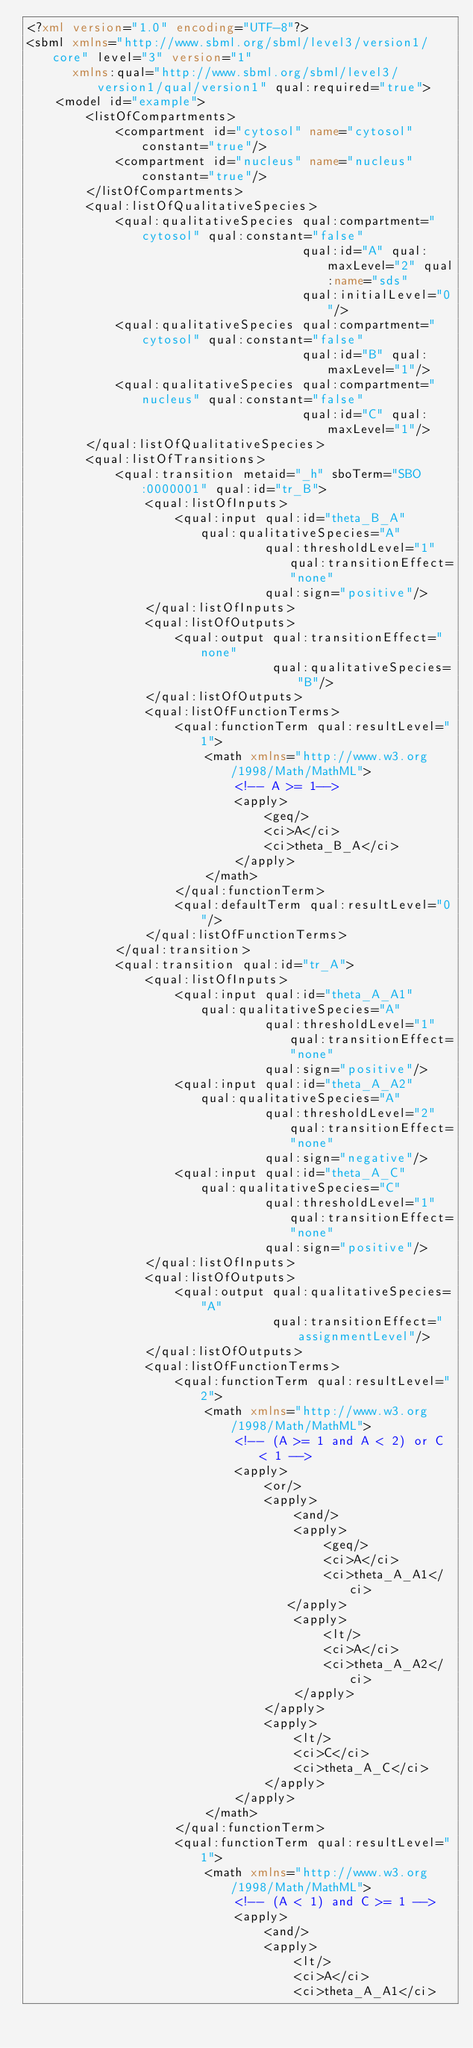<code> <loc_0><loc_0><loc_500><loc_500><_XML_><?xml version="1.0" encoding="UTF-8"?>
<sbml xmlns="http://www.sbml.org/sbml/level3/version1/core" level="3" version="1"
      xmlns:qual="http://www.sbml.org/sbml/level3/version1/qual/version1" qual:required="true">
    <model id="example">	
        <listOfCompartments>
            <compartment id="cytosol" name="cytosol" constant="true"/>
            <compartment id="nucleus" name="nucleus" constant="true"/>
        </listOfCompartments>
        <qual:listOfQualitativeSpecies>
            <qual:qualitativeSpecies qual:compartment="cytosol" qual:constant="false" 
                                     qual:id="A" qual:maxLevel="2" qual:name="sds"
                                     qual:initialLevel="0"/>
            <qual:qualitativeSpecies qual:compartment="cytosol" qual:constant="false" 
                                     qual:id="B" qual:maxLevel="1"/>
            <qual:qualitativeSpecies qual:compartment="nucleus" qual:constant="false" 
                                     qual:id="C" qual:maxLevel="1"/>
        </qual:listOfQualitativeSpecies>
        <qual:listOfTransitions>
            <qual:transition metaid="_h" sboTerm="SBO:0000001" qual:id="tr_B">
                <qual:listOfInputs>
                    <qual:input qual:id="theta_B_A"     qual:qualitativeSpecies="A" 
                                qual:thresholdLevel="1"  qual:transitionEffect="none" 
                                qual:sign="positive"/>
                </qual:listOfInputs>
                <qual:listOfOutputs>
                    <qual:output qual:transitionEffect="none" 
                                 qual:qualitativeSpecies="B"/>
                </qual:listOfOutputs>
                <qual:listOfFunctionTerms>
                    <qual:functionTerm qual:resultLevel="1">
                        <math xmlns="http://www.w3.org/1998/Math/MathML"> 
                            <!-- A >= 1-->
                            <apply>
                                <geq/>
                                <ci>A</ci>
                                <ci>theta_B_A</ci>
                            </apply>
                        </math>
                    </qual:functionTerm>
                    <qual:defaultTerm qual:resultLevel="0"/>
                </qual:listOfFunctionTerms>
            </qual:transition>
            <qual:transition qual:id="tr_A">
                <qual:listOfInputs>
                    <qual:input qual:id="theta_A_A1"     qual:qualitativeSpecies="A" 
                                qual:thresholdLevel="1"  qual:transitionEffect="none" 
                                qual:sign="positive"/>
                    <qual:input qual:id="theta_A_A2"     qual:qualitativeSpecies="A" 
                                qual:thresholdLevel="2"  qual:transitionEffect="none" 
                                qual:sign="negative"/>
                    <qual:input qual:id="theta_A_C"     qual:qualitativeSpecies="C" 
                                qual:thresholdLevel="1"  qual:transitionEffect="none" 
                                qual:sign="positive"/>
                </qual:listOfInputs>
                <qual:listOfOutputs>
                    <qual:output qual:qualitativeSpecies="A" 
                                 qual:transitionEffect="assignmentLevel"/>
                </qual:listOfOutputs>
                <qual:listOfFunctionTerms>
                    <qual:functionTerm qual:resultLevel="2">
                        <math xmlns="http://www.w3.org/1998/Math/MathML"> 
                            <!-- (A >= 1 and A < 2) or C < 1 -->
                            <apply>
                                <or/>
                                <apply>
                                    <and/>
                                    <apply>
                                        <geq/>
                                        <ci>A</ci>
                                        <ci>theta_A_A1</ci>
                                   </apply>
                                    <apply>
                                        <lt/>
                                        <ci>A</ci>
                                        <ci>theta_A_A2</ci>
                                    </apply>
                                </apply>
                                <apply>
                                    <lt/>
                                    <ci>C</ci>
                                    <ci>theta_A_C</ci>
                                </apply>
                            </apply>
                        </math>
                    </qual:functionTerm>
                    <qual:functionTerm qual:resultLevel="1">
                        <math xmlns="http://www.w3.org/1998/Math/MathML"> 
                            <!-- (A < 1) and C >= 1 -->
                            <apply>
                                <and/>
                                <apply>
                                    <lt/>
                                    <ci>A</ci>
                                    <ci>theta_A_A1</ci></code> 